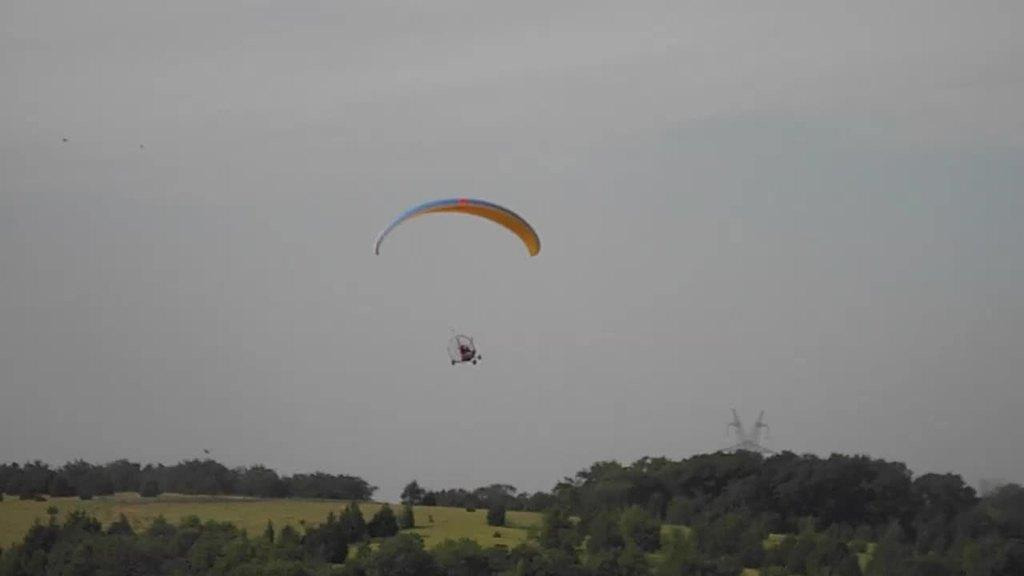What type of vegetation is at the bottom of the image? There are trees at the bottom of the image. What object can be seen in the middle of the image? There is a parachute in the middle of the image. What is visible at the top of the image? The sky is visible at the top of the image. What is the representative's tendency when it comes to cooking in the image? There is no representative or cooking activity present in the image. What type of cookware can be seen in the image? There is no cookware present in the image; it features trees, a parachute, and the sky. 